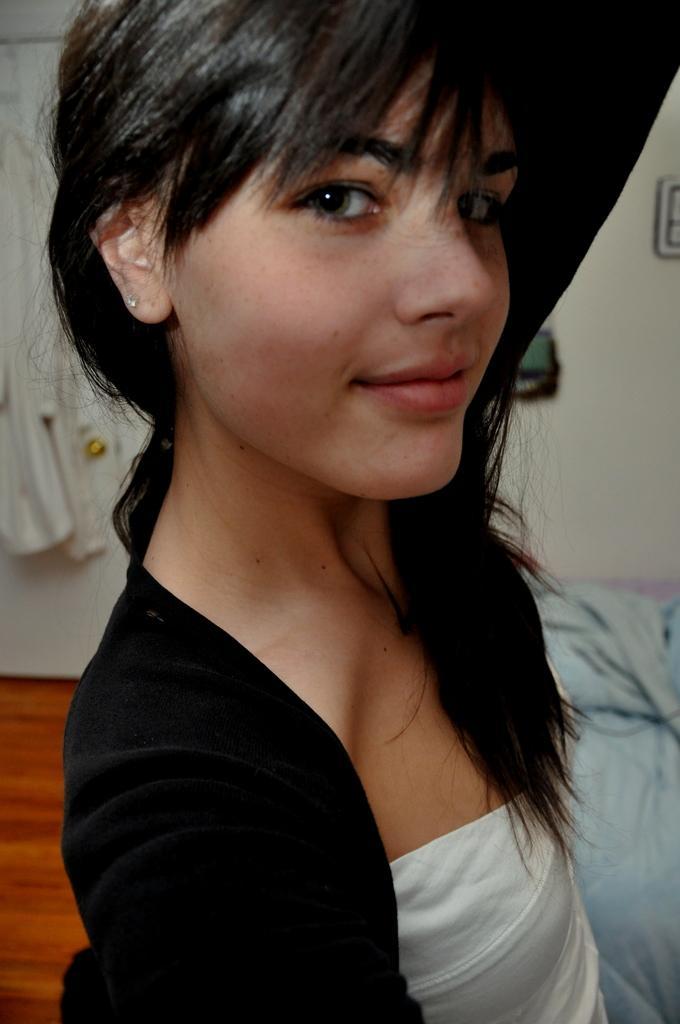Please provide a concise description of this image. In this image I can see the person is wearing black and white color dress. Back I can see the blue color blanket, wall, door and few objects. 